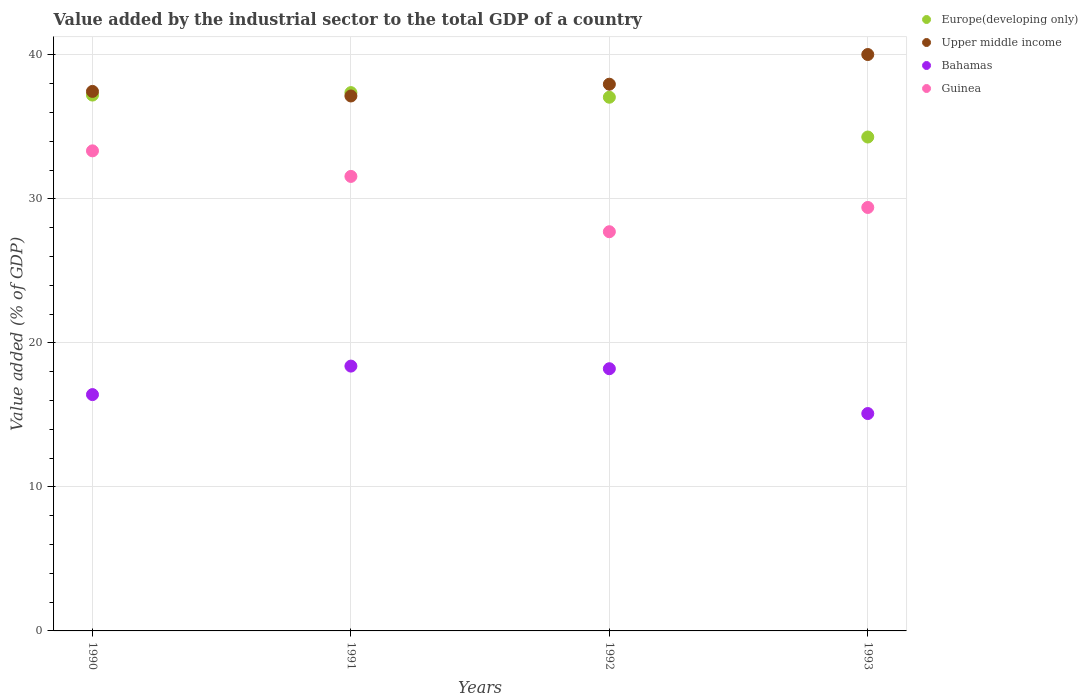Is the number of dotlines equal to the number of legend labels?
Keep it short and to the point. Yes. What is the value added by the industrial sector to the total GDP in Europe(developing only) in 1990?
Offer a terse response. 37.21. Across all years, what is the maximum value added by the industrial sector to the total GDP in Europe(developing only)?
Provide a succinct answer. 37.38. Across all years, what is the minimum value added by the industrial sector to the total GDP in Bahamas?
Offer a very short reply. 15.09. What is the total value added by the industrial sector to the total GDP in Bahamas in the graph?
Your response must be concise. 68.09. What is the difference between the value added by the industrial sector to the total GDP in Upper middle income in 1990 and that in 1993?
Provide a succinct answer. -2.56. What is the difference between the value added by the industrial sector to the total GDP in Guinea in 1991 and the value added by the industrial sector to the total GDP in Upper middle income in 1990?
Provide a succinct answer. -5.9. What is the average value added by the industrial sector to the total GDP in Europe(developing only) per year?
Your answer should be compact. 36.48. In the year 1990, what is the difference between the value added by the industrial sector to the total GDP in Upper middle income and value added by the industrial sector to the total GDP in Bahamas?
Give a very brief answer. 21.05. In how many years, is the value added by the industrial sector to the total GDP in Guinea greater than 22 %?
Offer a very short reply. 4. What is the ratio of the value added by the industrial sector to the total GDP in Bahamas in 1990 to that in 1992?
Make the answer very short. 0.9. Is the value added by the industrial sector to the total GDP in Europe(developing only) in 1991 less than that in 1993?
Offer a very short reply. No. What is the difference between the highest and the second highest value added by the industrial sector to the total GDP in Europe(developing only)?
Offer a very short reply. 0.17. What is the difference between the highest and the lowest value added by the industrial sector to the total GDP in Upper middle income?
Give a very brief answer. 2.88. In how many years, is the value added by the industrial sector to the total GDP in Bahamas greater than the average value added by the industrial sector to the total GDP in Bahamas taken over all years?
Provide a short and direct response. 2. Is the sum of the value added by the industrial sector to the total GDP in Europe(developing only) in 1990 and 1993 greater than the maximum value added by the industrial sector to the total GDP in Bahamas across all years?
Offer a terse response. Yes. Is it the case that in every year, the sum of the value added by the industrial sector to the total GDP in Upper middle income and value added by the industrial sector to the total GDP in Guinea  is greater than the value added by the industrial sector to the total GDP in Europe(developing only)?
Ensure brevity in your answer.  Yes. Are the values on the major ticks of Y-axis written in scientific E-notation?
Your answer should be compact. No. Does the graph contain any zero values?
Make the answer very short. No. Does the graph contain grids?
Make the answer very short. Yes. Where does the legend appear in the graph?
Your response must be concise. Top right. How are the legend labels stacked?
Your response must be concise. Vertical. What is the title of the graph?
Give a very brief answer. Value added by the industrial sector to the total GDP of a country. What is the label or title of the X-axis?
Provide a succinct answer. Years. What is the label or title of the Y-axis?
Keep it short and to the point. Value added (% of GDP). What is the Value added (% of GDP) in Europe(developing only) in 1990?
Ensure brevity in your answer.  37.21. What is the Value added (% of GDP) in Upper middle income in 1990?
Provide a succinct answer. 37.46. What is the Value added (% of GDP) of Bahamas in 1990?
Offer a very short reply. 16.41. What is the Value added (% of GDP) of Guinea in 1990?
Offer a terse response. 33.33. What is the Value added (% of GDP) of Europe(developing only) in 1991?
Your answer should be very brief. 37.38. What is the Value added (% of GDP) in Upper middle income in 1991?
Ensure brevity in your answer.  37.14. What is the Value added (% of GDP) in Bahamas in 1991?
Your response must be concise. 18.39. What is the Value added (% of GDP) of Guinea in 1991?
Keep it short and to the point. 31.56. What is the Value added (% of GDP) in Europe(developing only) in 1992?
Your answer should be very brief. 37.06. What is the Value added (% of GDP) of Upper middle income in 1992?
Provide a short and direct response. 37.96. What is the Value added (% of GDP) in Bahamas in 1992?
Give a very brief answer. 18.2. What is the Value added (% of GDP) in Guinea in 1992?
Provide a succinct answer. 27.72. What is the Value added (% of GDP) of Europe(developing only) in 1993?
Your response must be concise. 34.29. What is the Value added (% of GDP) of Upper middle income in 1993?
Offer a terse response. 40.02. What is the Value added (% of GDP) in Bahamas in 1993?
Your answer should be compact. 15.09. What is the Value added (% of GDP) in Guinea in 1993?
Provide a short and direct response. 29.4. Across all years, what is the maximum Value added (% of GDP) of Europe(developing only)?
Your response must be concise. 37.38. Across all years, what is the maximum Value added (% of GDP) in Upper middle income?
Provide a short and direct response. 40.02. Across all years, what is the maximum Value added (% of GDP) of Bahamas?
Offer a terse response. 18.39. Across all years, what is the maximum Value added (% of GDP) in Guinea?
Provide a short and direct response. 33.33. Across all years, what is the minimum Value added (% of GDP) in Europe(developing only)?
Provide a succinct answer. 34.29. Across all years, what is the minimum Value added (% of GDP) in Upper middle income?
Offer a very short reply. 37.14. Across all years, what is the minimum Value added (% of GDP) of Bahamas?
Offer a terse response. 15.09. Across all years, what is the minimum Value added (% of GDP) in Guinea?
Give a very brief answer. 27.72. What is the total Value added (% of GDP) of Europe(developing only) in the graph?
Your answer should be very brief. 145.93. What is the total Value added (% of GDP) in Upper middle income in the graph?
Give a very brief answer. 152.58. What is the total Value added (% of GDP) of Bahamas in the graph?
Offer a terse response. 68.09. What is the total Value added (% of GDP) of Guinea in the graph?
Make the answer very short. 122.01. What is the difference between the Value added (% of GDP) of Europe(developing only) in 1990 and that in 1991?
Offer a very short reply. -0.17. What is the difference between the Value added (% of GDP) in Upper middle income in 1990 and that in 1991?
Give a very brief answer. 0.32. What is the difference between the Value added (% of GDP) in Bahamas in 1990 and that in 1991?
Your answer should be compact. -1.98. What is the difference between the Value added (% of GDP) of Guinea in 1990 and that in 1991?
Give a very brief answer. 1.77. What is the difference between the Value added (% of GDP) of Europe(developing only) in 1990 and that in 1992?
Your response must be concise. 0.15. What is the difference between the Value added (% of GDP) in Upper middle income in 1990 and that in 1992?
Your answer should be very brief. -0.5. What is the difference between the Value added (% of GDP) in Bahamas in 1990 and that in 1992?
Your answer should be very brief. -1.8. What is the difference between the Value added (% of GDP) in Guinea in 1990 and that in 1992?
Offer a very short reply. 5.62. What is the difference between the Value added (% of GDP) in Europe(developing only) in 1990 and that in 1993?
Give a very brief answer. 2.91. What is the difference between the Value added (% of GDP) of Upper middle income in 1990 and that in 1993?
Your response must be concise. -2.56. What is the difference between the Value added (% of GDP) of Bahamas in 1990 and that in 1993?
Provide a short and direct response. 1.31. What is the difference between the Value added (% of GDP) of Guinea in 1990 and that in 1993?
Your response must be concise. 3.93. What is the difference between the Value added (% of GDP) of Europe(developing only) in 1991 and that in 1992?
Your answer should be compact. 0.32. What is the difference between the Value added (% of GDP) in Upper middle income in 1991 and that in 1992?
Provide a short and direct response. -0.82. What is the difference between the Value added (% of GDP) of Bahamas in 1991 and that in 1992?
Give a very brief answer. 0.18. What is the difference between the Value added (% of GDP) of Guinea in 1991 and that in 1992?
Keep it short and to the point. 3.84. What is the difference between the Value added (% of GDP) in Europe(developing only) in 1991 and that in 1993?
Make the answer very short. 3.08. What is the difference between the Value added (% of GDP) of Upper middle income in 1991 and that in 1993?
Provide a short and direct response. -2.88. What is the difference between the Value added (% of GDP) in Bahamas in 1991 and that in 1993?
Keep it short and to the point. 3.29. What is the difference between the Value added (% of GDP) of Guinea in 1991 and that in 1993?
Offer a very short reply. 2.16. What is the difference between the Value added (% of GDP) in Europe(developing only) in 1992 and that in 1993?
Offer a very short reply. 2.76. What is the difference between the Value added (% of GDP) in Upper middle income in 1992 and that in 1993?
Give a very brief answer. -2.06. What is the difference between the Value added (% of GDP) of Bahamas in 1992 and that in 1993?
Your answer should be compact. 3.11. What is the difference between the Value added (% of GDP) of Guinea in 1992 and that in 1993?
Ensure brevity in your answer.  -1.68. What is the difference between the Value added (% of GDP) of Europe(developing only) in 1990 and the Value added (% of GDP) of Upper middle income in 1991?
Your answer should be very brief. 0.06. What is the difference between the Value added (% of GDP) of Europe(developing only) in 1990 and the Value added (% of GDP) of Bahamas in 1991?
Ensure brevity in your answer.  18.82. What is the difference between the Value added (% of GDP) in Europe(developing only) in 1990 and the Value added (% of GDP) in Guinea in 1991?
Ensure brevity in your answer.  5.65. What is the difference between the Value added (% of GDP) in Upper middle income in 1990 and the Value added (% of GDP) in Bahamas in 1991?
Offer a terse response. 19.07. What is the difference between the Value added (% of GDP) in Upper middle income in 1990 and the Value added (% of GDP) in Guinea in 1991?
Keep it short and to the point. 5.9. What is the difference between the Value added (% of GDP) of Bahamas in 1990 and the Value added (% of GDP) of Guinea in 1991?
Your answer should be compact. -15.15. What is the difference between the Value added (% of GDP) of Europe(developing only) in 1990 and the Value added (% of GDP) of Upper middle income in 1992?
Offer a terse response. -0.75. What is the difference between the Value added (% of GDP) of Europe(developing only) in 1990 and the Value added (% of GDP) of Bahamas in 1992?
Keep it short and to the point. 19. What is the difference between the Value added (% of GDP) in Europe(developing only) in 1990 and the Value added (% of GDP) in Guinea in 1992?
Provide a succinct answer. 9.49. What is the difference between the Value added (% of GDP) of Upper middle income in 1990 and the Value added (% of GDP) of Bahamas in 1992?
Give a very brief answer. 19.25. What is the difference between the Value added (% of GDP) in Upper middle income in 1990 and the Value added (% of GDP) in Guinea in 1992?
Your answer should be compact. 9.74. What is the difference between the Value added (% of GDP) of Bahamas in 1990 and the Value added (% of GDP) of Guinea in 1992?
Offer a very short reply. -11.31. What is the difference between the Value added (% of GDP) in Europe(developing only) in 1990 and the Value added (% of GDP) in Upper middle income in 1993?
Offer a very short reply. -2.82. What is the difference between the Value added (% of GDP) in Europe(developing only) in 1990 and the Value added (% of GDP) in Bahamas in 1993?
Keep it short and to the point. 22.11. What is the difference between the Value added (% of GDP) in Europe(developing only) in 1990 and the Value added (% of GDP) in Guinea in 1993?
Your answer should be compact. 7.8. What is the difference between the Value added (% of GDP) in Upper middle income in 1990 and the Value added (% of GDP) in Bahamas in 1993?
Make the answer very short. 22.37. What is the difference between the Value added (% of GDP) in Upper middle income in 1990 and the Value added (% of GDP) in Guinea in 1993?
Keep it short and to the point. 8.06. What is the difference between the Value added (% of GDP) in Bahamas in 1990 and the Value added (% of GDP) in Guinea in 1993?
Keep it short and to the point. -12.99. What is the difference between the Value added (% of GDP) in Europe(developing only) in 1991 and the Value added (% of GDP) in Upper middle income in 1992?
Ensure brevity in your answer.  -0.58. What is the difference between the Value added (% of GDP) of Europe(developing only) in 1991 and the Value added (% of GDP) of Bahamas in 1992?
Your response must be concise. 19.17. What is the difference between the Value added (% of GDP) of Europe(developing only) in 1991 and the Value added (% of GDP) of Guinea in 1992?
Your answer should be compact. 9.66. What is the difference between the Value added (% of GDP) in Upper middle income in 1991 and the Value added (% of GDP) in Bahamas in 1992?
Your answer should be very brief. 18.94. What is the difference between the Value added (% of GDP) in Upper middle income in 1991 and the Value added (% of GDP) in Guinea in 1992?
Offer a very short reply. 9.43. What is the difference between the Value added (% of GDP) in Bahamas in 1991 and the Value added (% of GDP) in Guinea in 1992?
Your answer should be very brief. -9.33. What is the difference between the Value added (% of GDP) of Europe(developing only) in 1991 and the Value added (% of GDP) of Upper middle income in 1993?
Offer a terse response. -2.64. What is the difference between the Value added (% of GDP) in Europe(developing only) in 1991 and the Value added (% of GDP) in Bahamas in 1993?
Keep it short and to the point. 22.28. What is the difference between the Value added (% of GDP) in Europe(developing only) in 1991 and the Value added (% of GDP) in Guinea in 1993?
Your response must be concise. 7.97. What is the difference between the Value added (% of GDP) in Upper middle income in 1991 and the Value added (% of GDP) in Bahamas in 1993?
Give a very brief answer. 22.05. What is the difference between the Value added (% of GDP) in Upper middle income in 1991 and the Value added (% of GDP) in Guinea in 1993?
Offer a terse response. 7.74. What is the difference between the Value added (% of GDP) of Bahamas in 1991 and the Value added (% of GDP) of Guinea in 1993?
Make the answer very short. -11.01. What is the difference between the Value added (% of GDP) in Europe(developing only) in 1992 and the Value added (% of GDP) in Upper middle income in 1993?
Your answer should be very brief. -2.97. What is the difference between the Value added (% of GDP) of Europe(developing only) in 1992 and the Value added (% of GDP) of Bahamas in 1993?
Offer a very short reply. 21.96. What is the difference between the Value added (% of GDP) of Europe(developing only) in 1992 and the Value added (% of GDP) of Guinea in 1993?
Give a very brief answer. 7.65. What is the difference between the Value added (% of GDP) in Upper middle income in 1992 and the Value added (% of GDP) in Bahamas in 1993?
Your answer should be very brief. 22.87. What is the difference between the Value added (% of GDP) of Upper middle income in 1992 and the Value added (% of GDP) of Guinea in 1993?
Provide a short and direct response. 8.56. What is the difference between the Value added (% of GDP) in Bahamas in 1992 and the Value added (% of GDP) in Guinea in 1993?
Your answer should be very brief. -11.2. What is the average Value added (% of GDP) in Europe(developing only) per year?
Provide a succinct answer. 36.48. What is the average Value added (% of GDP) in Upper middle income per year?
Offer a very short reply. 38.15. What is the average Value added (% of GDP) of Bahamas per year?
Your answer should be very brief. 17.02. What is the average Value added (% of GDP) of Guinea per year?
Make the answer very short. 30.5. In the year 1990, what is the difference between the Value added (% of GDP) in Europe(developing only) and Value added (% of GDP) in Upper middle income?
Offer a very short reply. -0.25. In the year 1990, what is the difference between the Value added (% of GDP) in Europe(developing only) and Value added (% of GDP) in Bahamas?
Offer a terse response. 20.8. In the year 1990, what is the difference between the Value added (% of GDP) of Europe(developing only) and Value added (% of GDP) of Guinea?
Your response must be concise. 3.87. In the year 1990, what is the difference between the Value added (% of GDP) of Upper middle income and Value added (% of GDP) of Bahamas?
Offer a terse response. 21.05. In the year 1990, what is the difference between the Value added (% of GDP) in Upper middle income and Value added (% of GDP) in Guinea?
Offer a very short reply. 4.13. In the year 1990, what is the difference between the Value added (% of GDP) in Bahamas and Value added (% of GDP) in Guinea?
Make the answer very short. -16.92. In the year 1991, what is the difference between the Value added (% of GDP) in Europe(developing only) and Value added (% of GDP) in Upper middle income?
Make the answer very short. 0.23. In the year 1991, what is the difference between the Value added (% of GDP) in Europe(developing only) and Value added (% of GDP) in Bahamas?
Offer a very short reply. 18.99. In the year 1991, what is the difference between the Value added (% of GDP) of Europe(developing only) and Value added (% of GDP) of Guinea?
Ensure brevity in your answer.  5.82. In the year 1991, what is the difference between the Value added (% of GDP) in Upper middle income and Value added (% of GDP) in Bahamas?
Your answer should be compact. 18.75. In the year 1991, what is the difference between the Value added (% of GDP) in Upper middle income and Value added (% of GDP) in Guinea?
Your response must be concise. 5.58. In the year 1991, what is the difference between the Value added (% of GDP) in Bahamas and Value added (% of GDP) in Guinea?
Keep it short and to the point. -13.17. In the year 1992, what is the difference between the Value added (% of GDP) in Europe(developing only) and Value added (% of GDP) in Upper middle income?
Keep it short and to the point. -0.9. In the year 1992, what is the difference between the Value added (% of GDP) in Europe(developing only) and Value added (% of GDP) in Bahamas?
Your response must be concise. 18.85. In the year 1992, what is the difference between the Value added (% of GDP) in Europe(developing only) and Value added (% of GDP) in Guinea?
Make the answer very short. 9.34. In the year 1992, what is the difference between the Value added (% of GDP) in Upper middle income and Value added (% of GDP) in Bahamas?
Give a very brief answer. 19.75. In the year 1992, what is the difference between the Value added (% of GDP) of Upper middle income and Value added (% of GDP) of Guinea?
Keep it short and to the point. 10.24. In the year 1992, what is the difference between the Value added (% of GDP) in Bahamas and Value added (% of GDP) in Guinea?
Make the answer very short. -9.51. In the year 1993, what is the difference between the Value added (% of GDP) of Europe(developing only) and Value added (% of GDP) of Upper middle income?
Keep it short and to the point. -5.73. In the year 1993, what is the difference between the Value added (% of GDP) of Europe(developing only) and Value added (% of GDP) of Bahamas?
Ensure brevity in your answer.  19.2. In the year 1993, what is the difference between the Value added (% of GDP) in Europe(developing only) and Value added (% of GDP) in Guinea?
Make the answer very short. 4.89. In the year 1993, what is the difference between the Value added (% of GDP) in Upper middle income and Value added (% of GDP) in Bahamas?
Your answer should be very brief. 24.93. In the year 1993, what is the difference between the Value added (% of GDP) in Upper middle income and Value added (% of GDP) in Guinea?
Ensure brevity in your answer.  10.62. In the year 1993, what is the difference between the Value added (% of GDP) of Bahamas and Value added (% of GDP) of Guinea?
Make the answer very short. -14.31. What is the ratio of the Value added (% of GDP) of Europe(developing only) in 1990 to that in 1991?
Provide a short and direct response. 1. What is the ratio of the Value added (% of GDP) of Upper middle income in 1990 to that in 1991?
Provide a succinct answer. 1.01. What is the ratio of the Value added (% of GDP) in Bahamas in 1990 to that in 1991?
Your answer should be compact. 0.89. What is the ratio of the Value added (% of GDP) of Guinea in 1990 to that in 1991?
Give a very brief answer. 1.06. What is the ratio of the Value added (% of GDP) in Europe(developing only) in 1990 to that in 1992?
Give a very brief answer. 1. What is the ratio of the Value added (% of GDP) of Bahamas in 1990 to that in 1992?
Your answer should be compact. 0.9. What is the ratio of the Value added (% of GDP) of Guinea in 1990 to that in 1992?
Provide a short and direct response. 1.2. What is the ratio of the Value added (% of GDP) in Europe(developing only) in 1990 to that in 1993?
Offer a terse response. 1.08. What is the ratio of the Value added (% of GDP) of Upper middle income in 1990 to that in 1993?
Offer a terse response. 0.94. What is the ratio of the Value added (% of GDP) in Bahamas in 1990 to that in 1993?
Ensure brevity in your answer.  1.09. What is the ratio of the Value added (% of GDP) of Guinea in 1990 to that in 1993?
Give a very brief answer. 1.13. What is the ratio of the Value added (% of GDP) of Europe(developing only) in 1991 to that in 1992?
Keep it short and to the point. 1.01. What is the ratio of the Value added (% of GDP) of Upper middle income in 1991 to that in 1992?
Your answer should be very brief. 0.98. What is the ratio of the Value added (% of GDP) in Bahamas in 1991 to that in 1992?
Provide a short and direct response. 1.01. What is the ratio of the Value added (% of GDP) in Guinea in 1991 to that in 1992?
Provide a short and direct response. 1.14. What is the ratio of the Value added (% of GDP) in Europe(developing only) in 1991 to that in 1993?
Provide a short and direct response. 1.09. What is the ratio of the Value added (% of GDP) of Upper middle income in 1991 to that in 1993?
Keep it short and to the point. 0.93. What is the ratio of the Value added (% of GDP) in Bahamas in 1991 to that in 1993?
Keep it short and to the point. 1.22. What is the ratio of the Value added (% of GDP) of Guinea in 1991 to that in 1993?
Keep it short and to the point. 1.07. What is the ratio of the Value added (% of GDP) of Europe(developing only) in 1992 to that in 1993?
Keep it short and to the point. 1.08. What is the ratio of the Value added (% of GDP) in Upper middle income in 1992 to that in 1993?
Your response must be concise. 0.95. What is the ratio of the Value added (% of GDP) in Bahamas in 1992 to that in 1993?
Your answer should be very brief. 1.21. What is the ratio of the Value added (% of GDP) in Guinea in 1992 to that in 1993?
Your response must be concise. 0.94. What is the difference between the highest and the second highest Value added (% of GDP) in Europe(developing only)?
Make the answer very short. 0.17. What is the difference between the highest and the second highest Value added (% of GDP) of Upper middle income?
Offer a very short reply. 2.06. What is the difference between the highest and the second highest Value added (% of GDP) of Bahamas?
Offer a very short reply. 0.18. What is the difference between the highest and the second highest Value added (% of GDP) of Guinea?
Keep it short and to the point. 1.77. What is the difference between the highest and the lowest Value added (% of GDP) of Europe(developing only)?
Offer a terse response. 3.08. What is the difference between the highest and the lowest Value added (% of GDP) of Upper middle income?
Make the answer very short. 2.88. What is the difference between the highest and the lowest Value added (% of GDP) of Bahamas?
Offer a very short reply. 3.29. What is the difference between the highest and the lowest Value added (% of GDP) in Guinea?
Your answer should be compact. 5.62. 